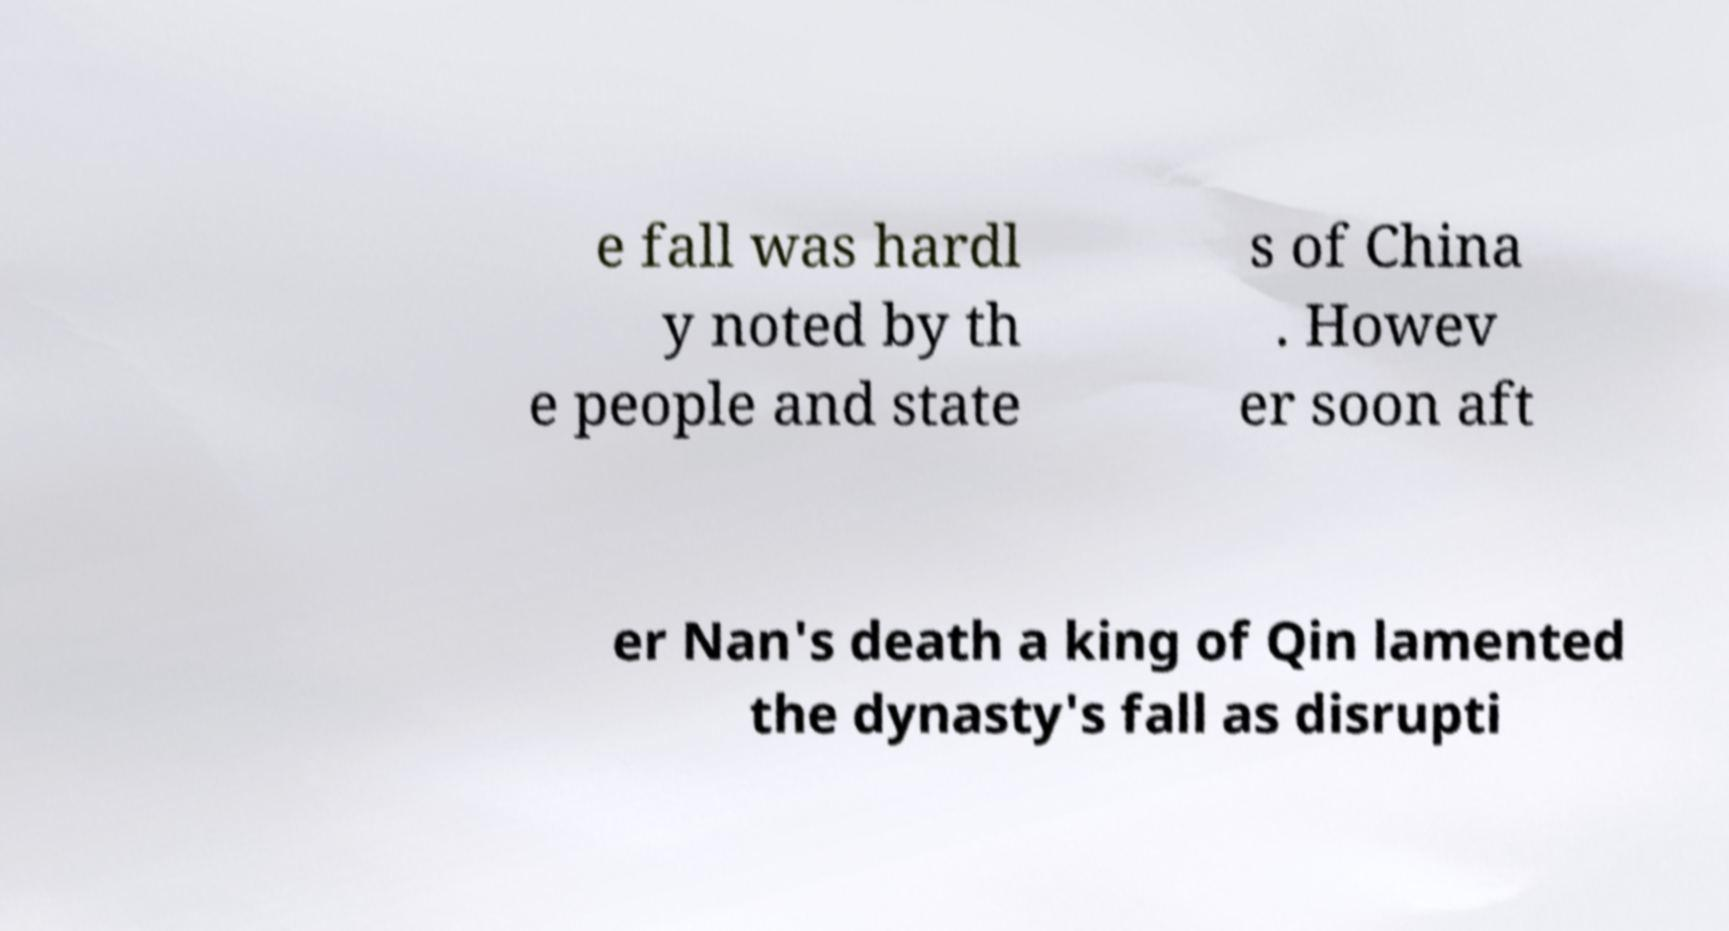Can you accurately transcribe the text from the provided image for me? e fall was hardl y noted by th e people and state s of China . Howev er soon aft er Nan's death a king of Qin lamented the dynasty's fall as disrupti 